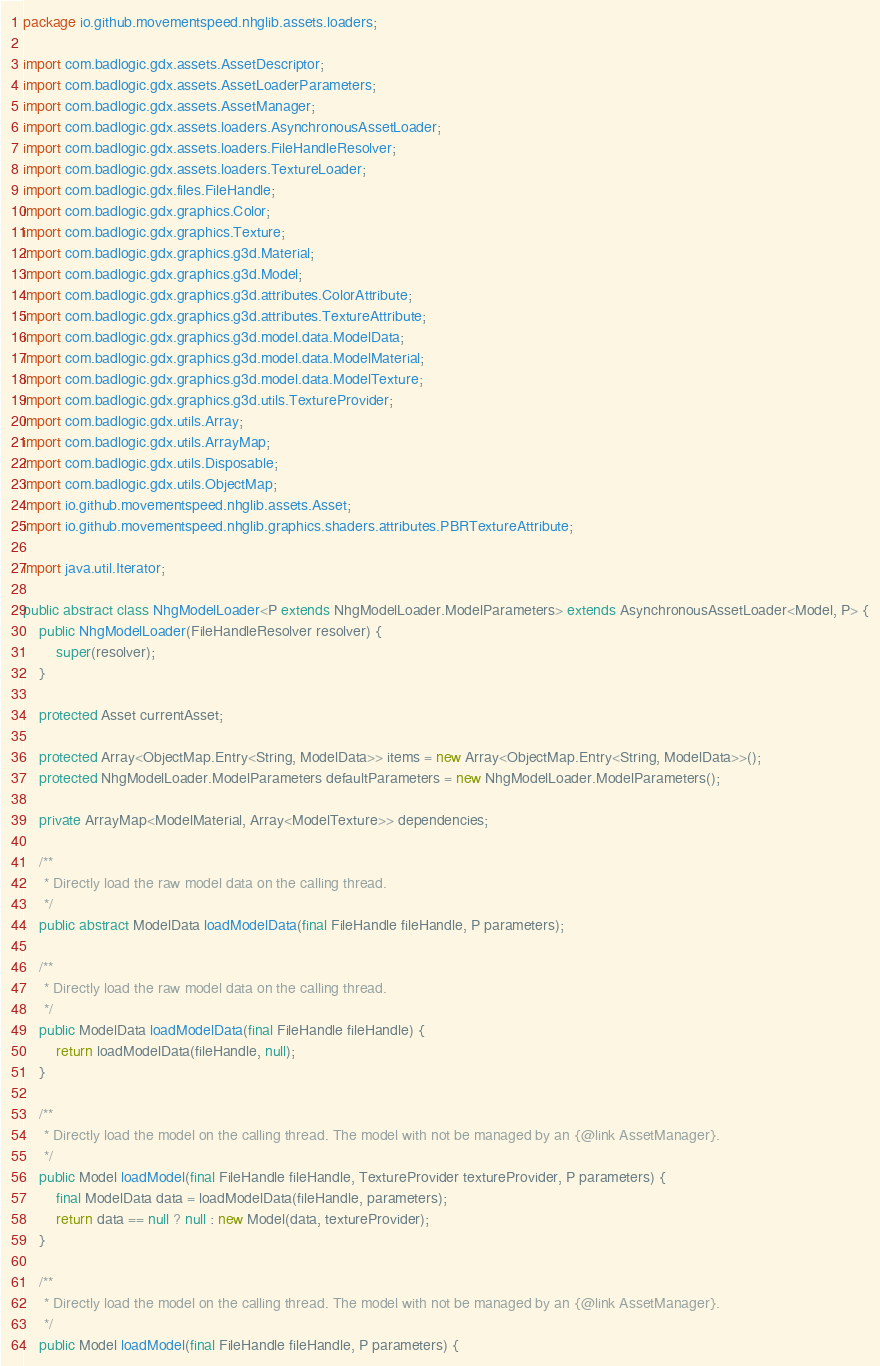<code> <loc_0><loc_0><loc_500><loc_500><_Java_>package io.github.movementspeed.nhglib.assets.loaders;

import com.badlogic.gdx.assets.AssetDescriptor;
import com.badlogic.gdx.assets.AssetLoaderParameters;
import com.badlogic.gdx.assets.AssetManager;
import com.badlogic.gdx.assets.loaders.AsynchronousAssetLoader;
import com.badlogic.gdx.assets.loaders.FileHandleResolver;
import com.badlogic.gdx.assets.loaders.TextureLoader;
import com.badlogic.gdx.files.FileHandle;
import com.badlogic.gdx.graphics.Color;
import com.badlogic.gdx.graphics.Texture;
import com.badlogic.gdx.graphics.g3d.Material;
import com.badlogic.gdx.graphics.g3d.Model;
import com.badlogic.gdx.graphics.g3d.attributes.ColorAttribute;
import com.badlogic.gdx.graphics.g3d.attributes.TextureAttribute;
import com.badlogic.gdx.graphics.g3d.model.data.ModelData;
import com.badlogic.gdx.graphics.g3d.model.data.ModelMaterial;
import com.badlogic.gdx.graphics.g3d.model.data.ModelTexture;
import com.badlogic.gdx.graphics.g3d.utils.TextureProvider;
import com.badlogic.gdx.utils.Array;
import com.badlogic.gdx.utils.ArrayMap;
import com.badlogic.gdx.utils.Disposable;
import com.badlogic.gdx.utils.ObjectMap;
import io.github.movementspeed.nhglib.assets.Asset;
import io.github.movementspeed.nhglib.graphics.shaders.attributes.PBRTextureAttribute;

import java.util.Iterator;

public abstract class NhgModelLoader<P extends NhgModelLoader.ModelParameters> extends AsynchronousAssetLoader<Model, P> {
    public NhgModelLoader(FileHandleResolver resolver) {
        super(resolver);
    }

    protected Asset currentAsset;

    protected Array<ObjectMap.Entry<String, ModelData>> items = new Array<ObjectMap.Entry<String, ModelData>>();
    protected NhgModelLoader.ModelParameters defaultParameters = new NhgModelLoader.ModelParameters();

    private ArrayMap<ModelMaterial, Array<ModelTexture>> dependencies;

    /**
     * Directly load the raw model data on the calling thread.
     */
    public abstract ModelData loadModelData(final FileHandle fileHandle, P parameters);

    /**
     * Directly load the raw model data on the calling thread.
     */
    public ModelData loadModelData(final FileHandle fileHandle) {
        return loadModelData(fileHandle, null);
    }

    /**
     * Directly load the model on the calling thread. The model with not be managed by an {@link AssetManager}.
     */
    public Model loadModel(final FileHandle fileHandle, TextureProvider textureProvider, P parameters) {
        final ModelData data = loadModelData(fileHandle, parameters);
        return data == null ? null : new Model(data, textureProvider);
    }

    /**
     * Directly load the model on the calling thread. The model with not be managed by an {@link AssetManager}.
     */
    public Model loadModel(final FileHandle fileHandle, P parameters) {</code> 